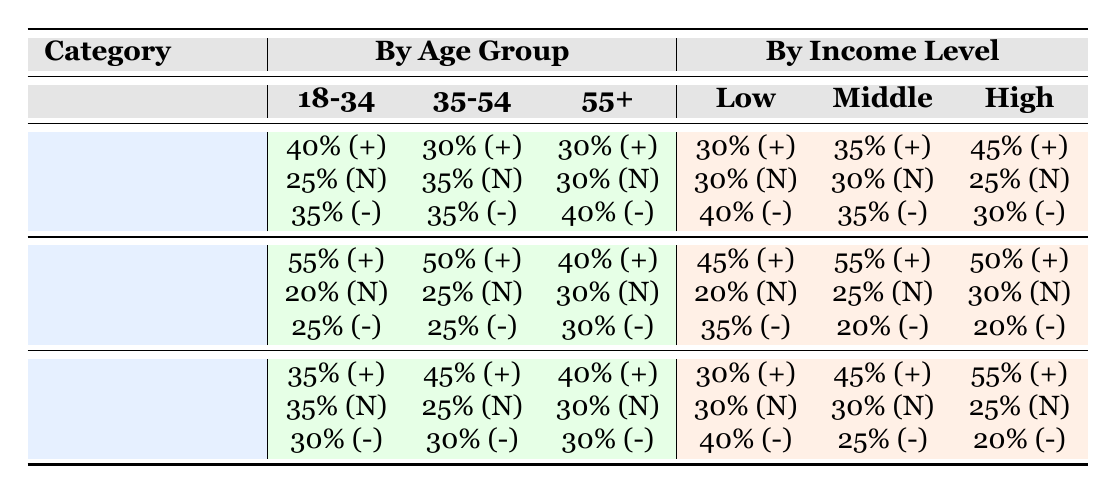What percentage of the 18-34 age group is satisfied with healthcare? According to the table, the percentage of the 18-34 age group that is satisfied with healthcare (positive sentiment) is 40%.
Answer: 40% What is the overall sentiment for education across all demographics? The overall sentiment for education is 50% positive, 25% neutral, and 25% negative.
Answer: 50% positive, 25% neutral, 25% negative Which income level group has the highest percentage of positive sentiment towards infrastructure? When checking the income level groups, the high-income group has the highest percentage of positive sentiment towards infrastructure at 55%.
Answer: 55% What is the difference in positive sentiment between low-income and middle-income groups for healthcare? The positive sentiment for the low-income group is 30%, and for the middle-income group, it is 35%. The difference is 35% - 30% = 5%.
Answer: 5% Is it true that the majority (more than 50%) of the 55+ age group is satisfied with healthcare? The percentages for the 55+ age group regarding healthcare are 30% positive, 30% neutral, and 40% negative. Thus, the majority is not satisfied (50% or more), making this statement false.
Answer: No What is the average percentage of positive sentiment for education across the different age groups? The positive sentiments for education across the age groups are 55%, 50%, and 40%. To find the average, we sum these values: 55 + 50 + 40 = 145, and then divide by 3: 145/3 = approximately 48.33%.
Answer: Approximately 48.33% How do the positive sentiments for infrastructure differ from healthcare in the 35-54 age group? The positive sentiment for healthcare in the 35-54 age group is 30%, while for infrastructure, it is 45%. The difference is 45% - 30% = 15%.
Answer: 15% For low-income individuals, how does the percentage of negative sentiment for education compare to that for healthcare? For low-income individuals, the negative sentiment for education is 35%, and for healthcare, it is 40%. Comparing these two, 40% is greater than 35%, indicating that there’s a higher percentage of negative sentiment for healthcare.
Answer: Higher for healthcare What total percentage of the 18-34 age group feels neutral towards infrastructure? The neutral sentiment for the 18-34 age group regarding infrastructure is 35%.
Answer: 35% 